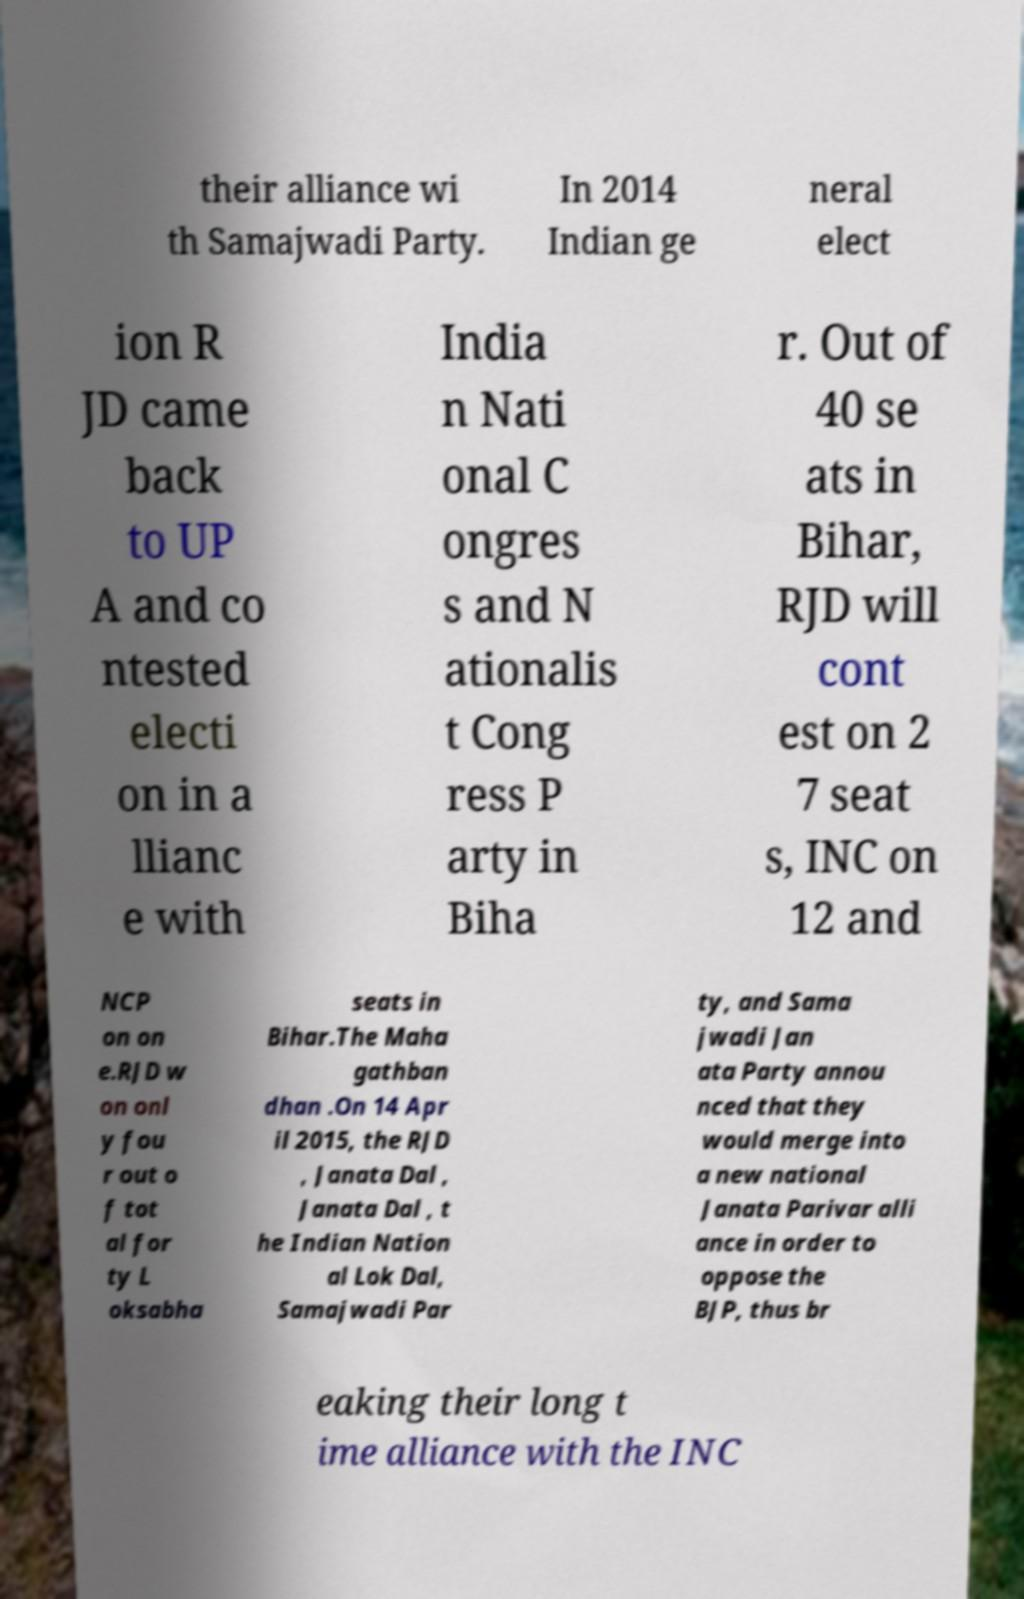Could you extract and type out the text from this image? their alliance wi th Samajwadi Party. In 2014 Indian ge neral elect ion R JD came back to UP A and co ntested electi on in a llianc e with India n Nati onal C ongres s and N ationalis t Cong ress P arty in Biha r. Out of 40 se ats in Bihar, RJD will cont est on 2 7 seat s, INC on 12 and NCP on on e.RJD w on onl y fou r out o f tot al for ty L oksabha seats in Bihar.The Maha gathban dhan .On 14 Apr il 2015, the RJD , Janata Dal , Janata Dal , t he Indian Nation al Lok Dal, Samajwadi Par ty, and Sama jwadi Jan ata Party annou nced that they would merge into a new national Janata Parivar alli ance in order to oppose the BJP, thus br eaking their long t ime alliance with the INC 